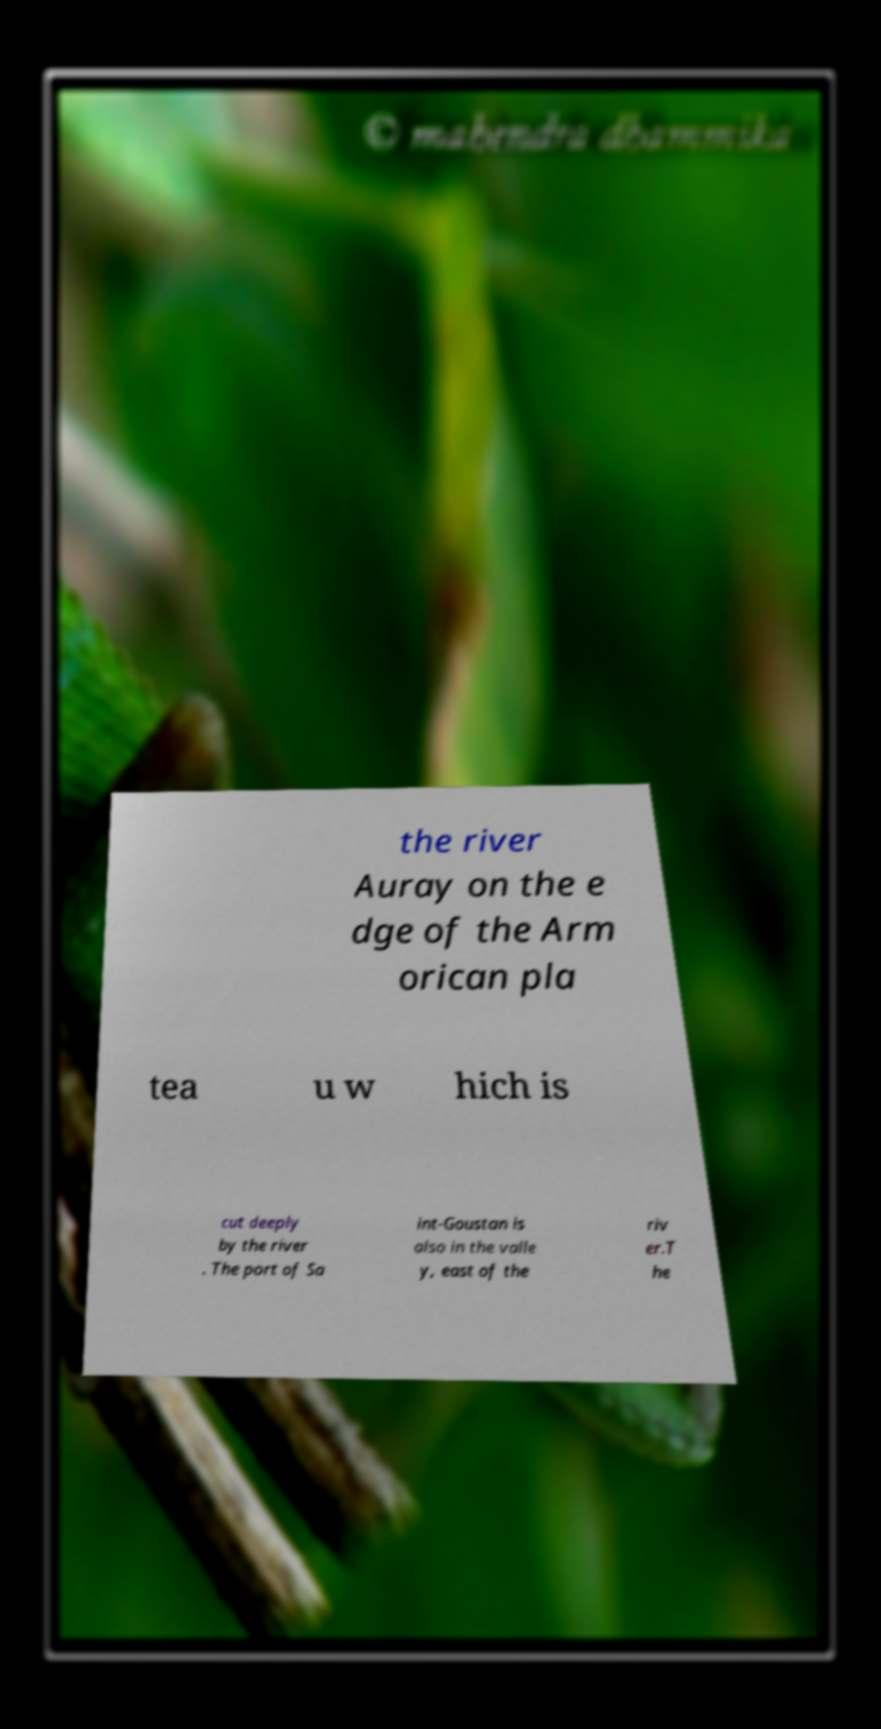Please identify and transcribe the text found in this image. the river Auray on the e dge of the Arm orican pla tea u w hich is cut deeply by the river . The port of Sa int-Goustan is also in the valle y, east of the riv er.T he 